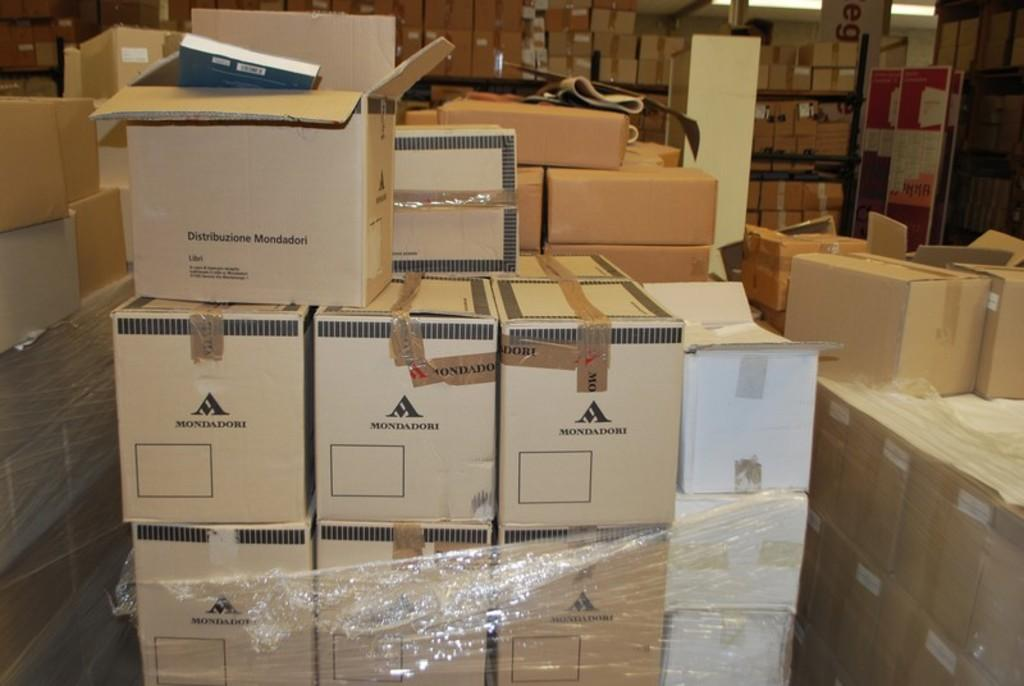<image>
Create a compact narrative representing the image presented. Boxes with a Mondadori logo are stacked on top of each other. 